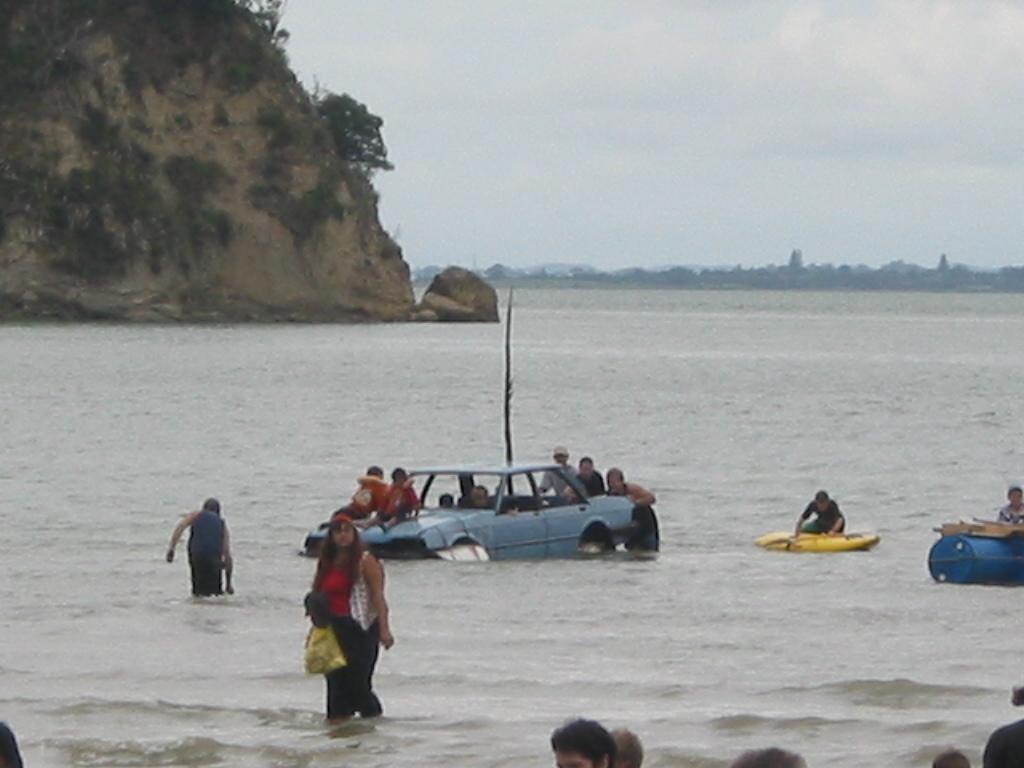Please provide a concise description of this image. In this image I can see a vehicle in the water. In the vehicle I can see few persons sitting, I can also see a boat which is in yellow color and a person sitting in the boat. In front I can see few persons walking in the water, rock in brown color, trees in green color and the sky is in white color. 